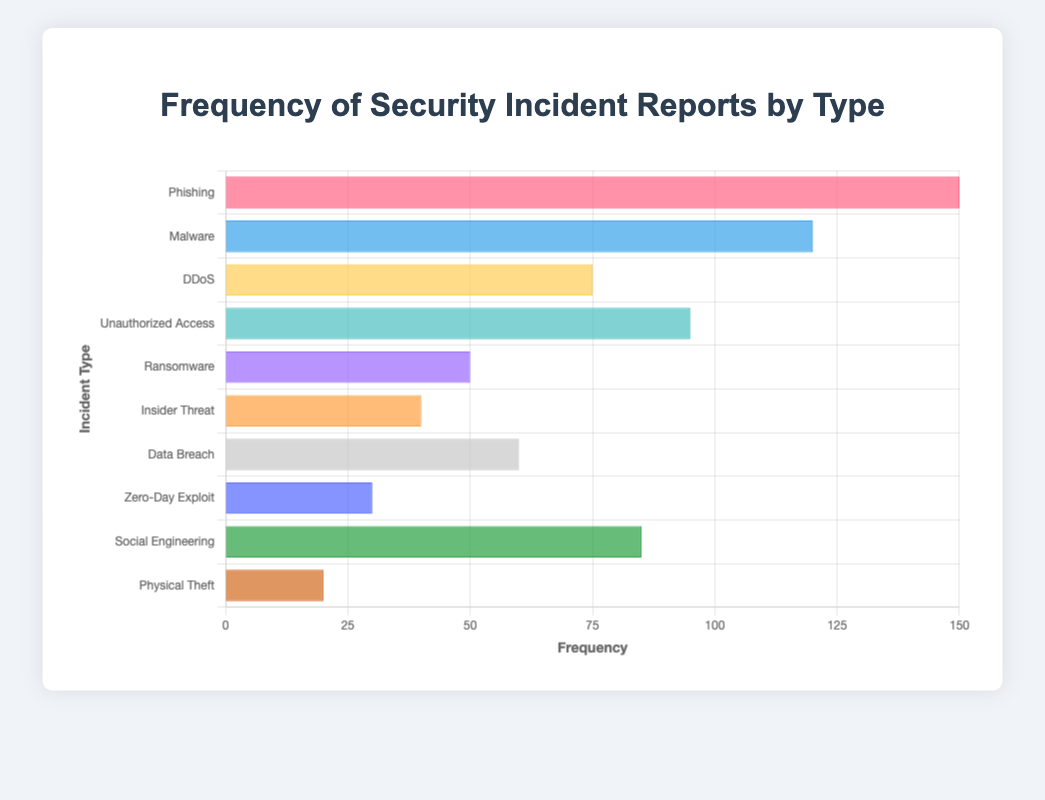Which incident type has the highest frequency? By examining the chart, the Phishing bar is the longest, indicating the highest frequency.
Answer: Phishing Which incident type has the lowest frequency? The bar for Physical Theft is the shortest, indicating the lowest frequency.
Answer: Physical Theft How many more reports are there for Phishing than Malware? The frequency of Phishing is 150, and the frequency of Malware is 120. The difference is 150 - 120.
Answer: 30 What is the sum of the frequencies for Ransomware, Insider Threat, and Data Breach? Adding the frequencies: Ransomware (50) + Insider Threat (40) + Data Breach (60) results in 50 + 40 + 60.
Answer: 150 Which two incident types have a combined frequency of 195? The bars for Unauthorized Access (95) and Phishing (100) add up to 95 + 100.
Answer: Unauthorized Access and Social Engineering What is the average frequency of all the security incidents? Sum the frequencies: 150 + 120 + 75 + 95 + 50 + 40 + 60 + 30 + 85 + 20 = 725. Divide by the number of types, which is 10.
Answer: 72.5 Which incident is more frequent: DDoS or Unauthorized Access? Compare the lengths of the bars for DDoS (75) and Unauthorized Access (95). Unauthorized Access has a longer bar.
Answer: Unauthorized Access Which incident types have fewer than 50 reports? The bars for Physical Theft (20), Zero-Day Exploit (30), and Insider Threat (40) are less than the 50 mark on the x-axis.
Answer: Physical Theft, Zero-Day Exploit, and Insider Threat What is the difference in frequency between the highest and the lowest reported incident types? The highest frequency is Phishing (150) and the lowest is Physical Theft (20). The difference is 150 - 20.
Answer: 130 